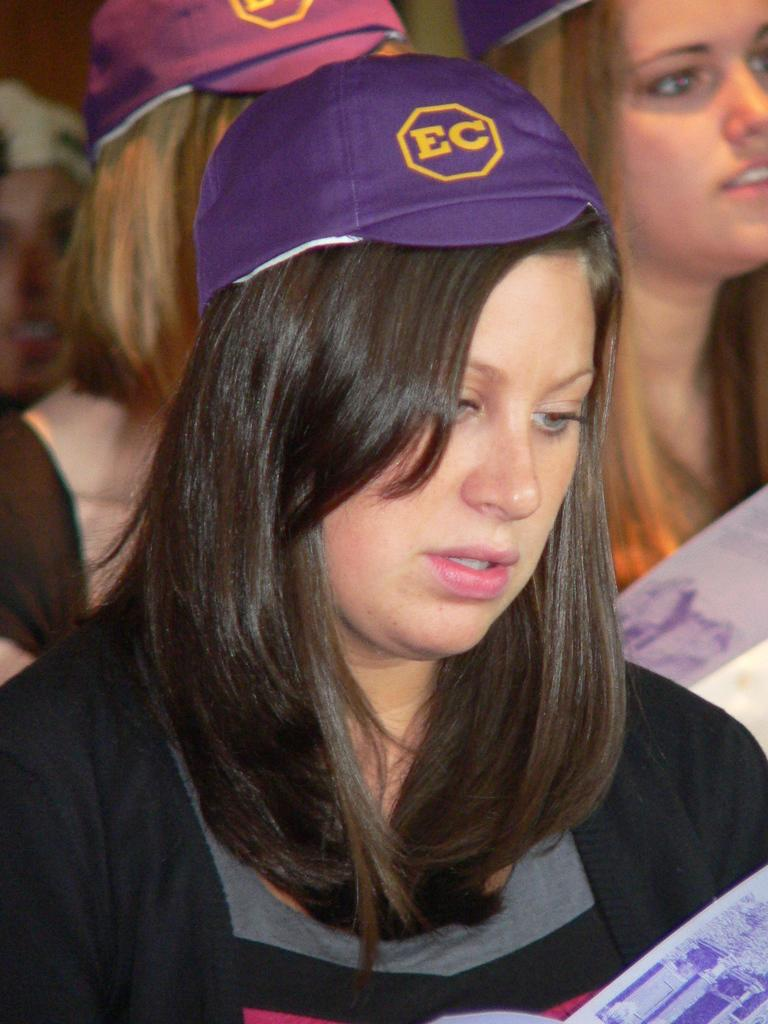<image>
Provide a brief description of the given image. Young lady with a purple hat on that has a octagon shape with EC printed on it. 